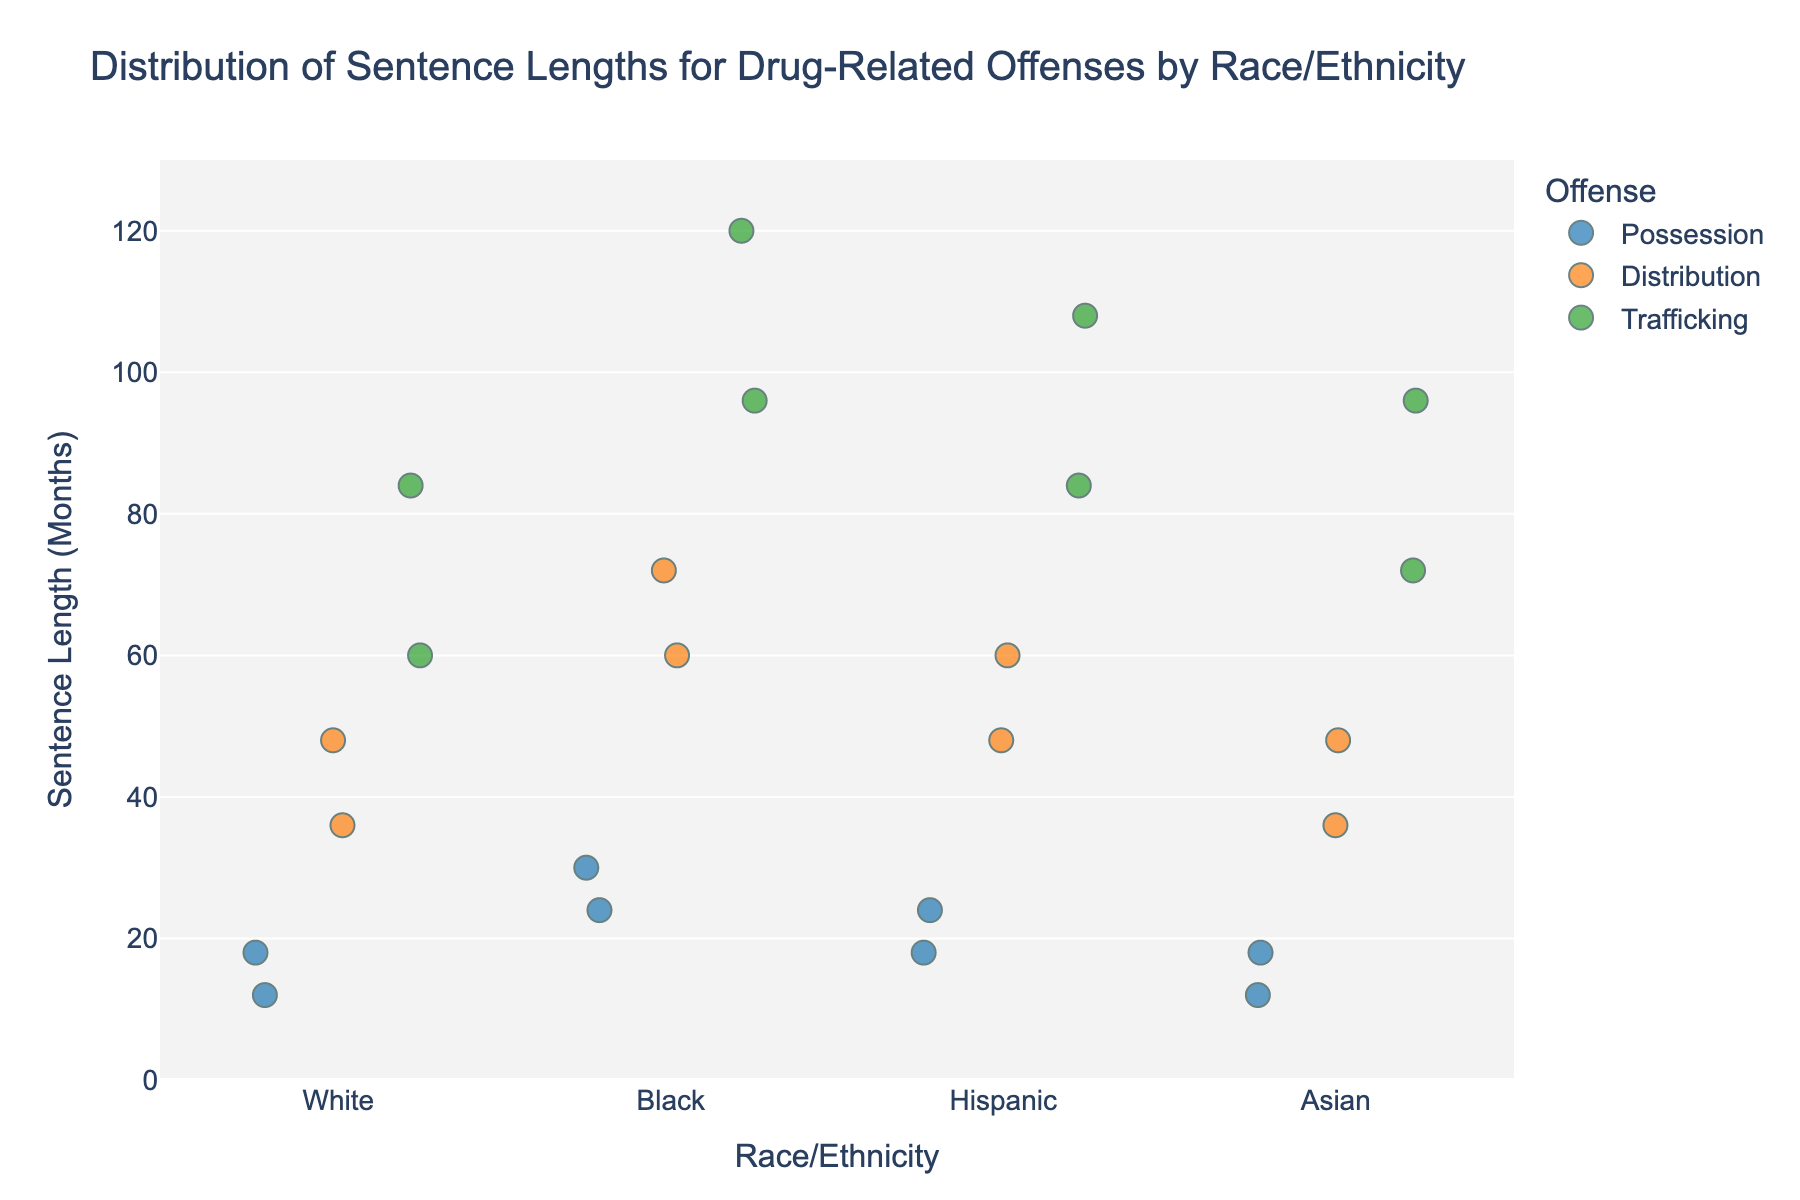what is the title of this strip plot? The title is usually at the top of the figure. It indicates the main subject of the plot, which in this case is the "Distribution of Sentence Lengths for Drug-Related Offenses by Race/Ethnicity".
Answer: Distribution of Sentence Lengths for Drug-Related Offenses by Race/Ethnicity What is the range of sentence lengths shown on the y-axis? The y-axis represents sentence length in months and usually clearly shows the range in the figure. In this case, it ranges from 0 to 130 months.
Answer: 0 to 130 months What offense category does a green marker indicate? According to the color legend provided in the plot, different offenses are represented by different colors. The green marker represents "Trafficking".
Answer: Trafficking What is the longest sentence length recorded for a Black individual? By analyzing the distribution of dots within the "Black" category and identifying the highest point, we can see that the longest sentence length is 120 months.
Answer: 120 months Compare the average sentence length for the "Possession" offense between White and Black individuals. The average sentence length for the "Possession" offense for White individuals can be calculated by averaging the two points (12 and 18), which is (12+18)/2 = 15 months. For Black individuals, it is (24 + 30) / 2 = 27 months.
Answer: White: 15 months, Black: 27 months Which racial/ethnic group has the widest range of sentence lengths for the "Distribution" offense? By examining the spread of dots for the "Distribution" offense across different racial/ethnic groups, we see that Black individuals show sentence lengths from 60 to 72, giving a range of 12 months. Hispanics show a range of 12 months (48-60), Asians show 12 months (36-48), and Whites show 12 months (36-48). All groups have the same range.
Answer: All groups have the same range What is the shortest recorded sentence length for Hispanic individuals? By identifying the lowest point in the "Hispanic" category across all offenses, we see the shortest sentence length recorded is 18 months.
Answer: 18 months Which offense category shows the most variation in sentence lengths within the "Asian" category? We can compare the sentence length variations within each offense category for Asians. Possession ranges from 12 to 18 months (6 months range), Distribution from 36 to 48 months (12 months range), and Trafficking from 72 to 96 months (24 months range).
Answer: Trafficking For which racial/ethnic group and offense category combination is the difference between the minimum and maximum sentence lengths the smallest? By examining each group and offense combination, the "Possession" offense in the White group shows the smallest range from 12 to 18 months (6 months range).
Answer: White (Possession) 